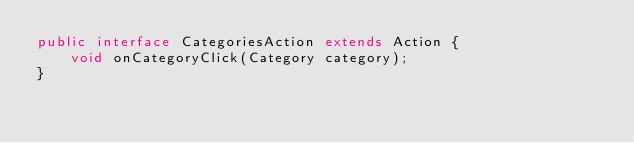<code> <loc_0><loc_0><loc_500><loc_500><_Java_>public interface CategoriesAction extends Action {
    void onCategoryClick(Category category);
}
</code> 